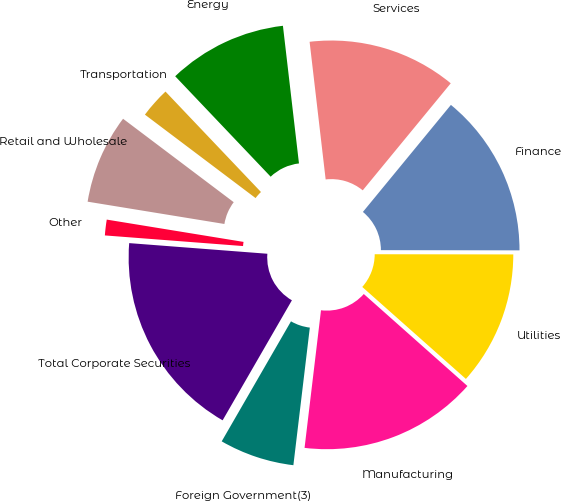Convert chart to OTSL. <chart><loc_0><loc_0><loc_500><loc_500><pie_chart><fcel>Manufacturing<fcel>Utilities<fcel>Finance<fcel>Services<fcel>Energy<fcel>Transportation<fcel>Retail and Wholesale<fcel>Other<fcel>Total Corporate Securities<fcel>Foreign Government(3)<nl><fcel>15.34%<fcel>11.53%<fcel>14.07%<fcel>12.8%<fcel>10.25%<fcel>2.62%<fcel>7.71%<fcel>1.35%<fcel>17.89%<fcel>6.44%<nl></chart> 